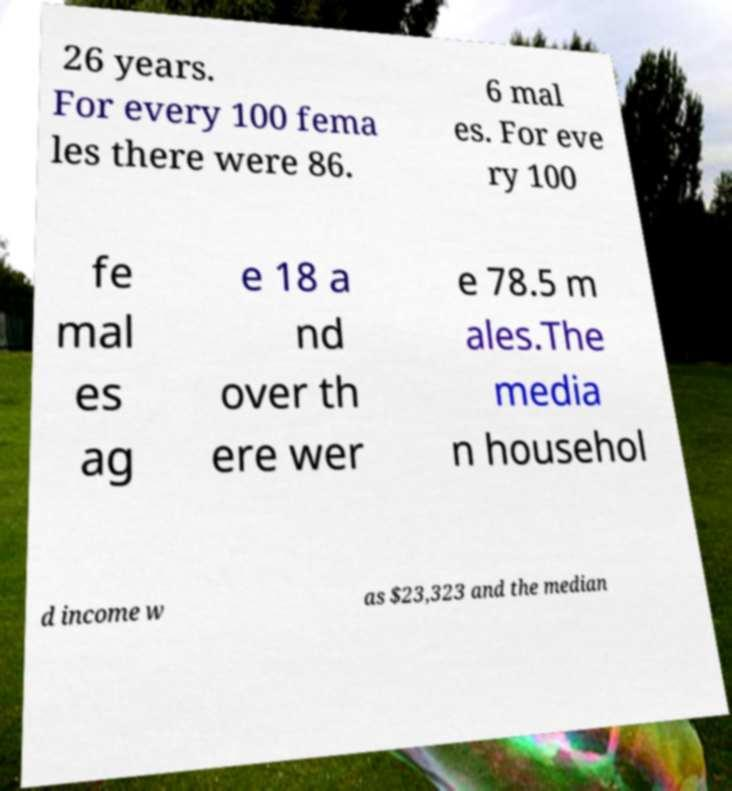Can you accurately transcribe the text from the provided image for me? 26 years. For every 100 fema les there were 86. 6 mal es. For eve ry 100 fe mal es ag e 18 a nd over th ere wer e 78.5 m ales.The media n househol d income w as $23,323 and the median 